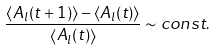<formula> <loc_0><loc_0><loc_500><loc_500>\frac { \left < A _ { l } ( t + 1 ) \right > - \left < A _ { l } ( t ) \right > } { \left < A _ { l } ( t ) \right > } \sim c o n s t .</formula> 